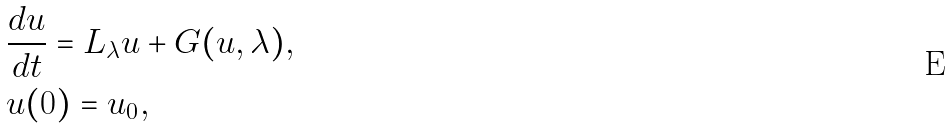Convert formula to latex. <formula><loc_0><loc_0><loc_500><loc_500>& \frac { d u } { d t } = L _ { \lambda } u + G ( u , \lambda ) , \\ & u ( 0 ) = u _ { 0 } ,</formula> 